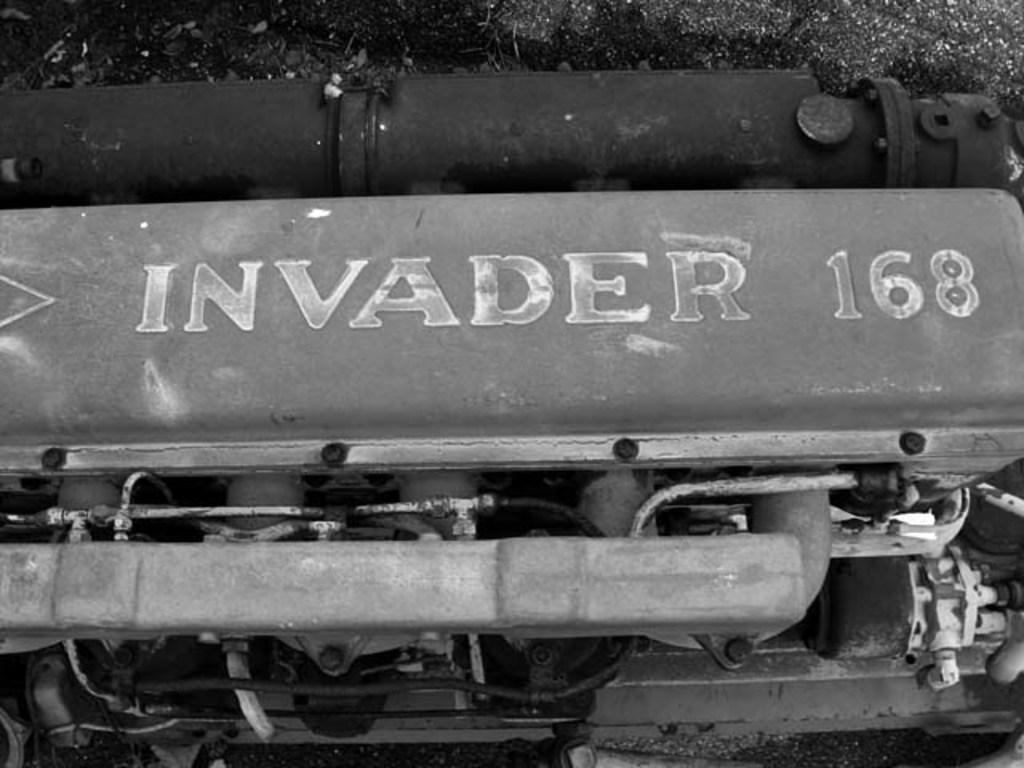<image>
Relay a brief, clear account of the picture shown. A black and white image shows Invader 168 in faded white paint. 